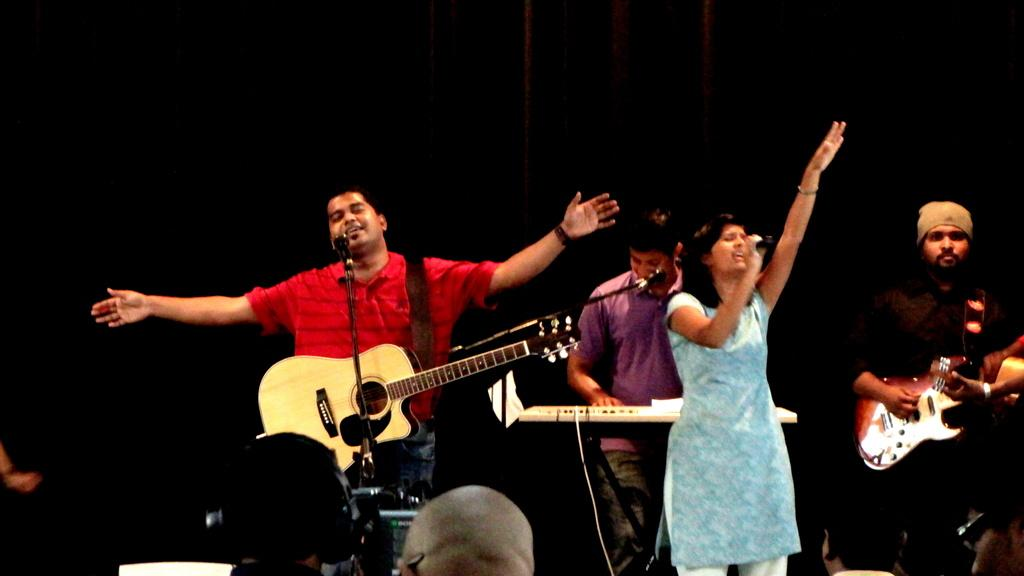What are the people in the image doing? The people in the image are performing. What activity are the people engaged in while performing? They are playing musical instruments. What device is present in the image that might be used for amplifying sound? A microphone is present in the image. How many uncles are playing the guitar in the image? There is no mention of uncles or guitars in the image; the people are playing musical instruments, but their relationship to each other is not specified. 